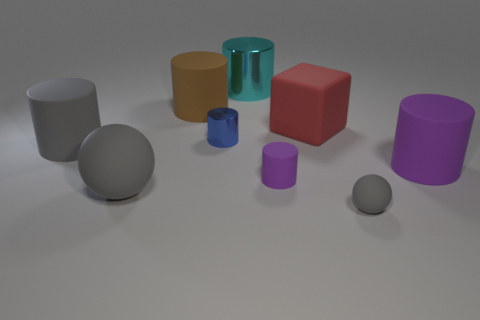Subtract 1 cylinders. How many cylinders are left? 5 Subtract all purple cylinders. How many cylinders are left? 4 Subtract all small cylinders. How many cylinders are left? 4 Subtract all cyan cylinders. Subtract all green balls. How many cylinders are left? 5 Add 1 big blue matte spheres. How many objects exist? 10 Subtract all cubes. How many objects are left? 8 Add 3 big cyan things. How many big cyan things are left? 4 Add 4 big purple objects. How many big purple objects exist? 5 Subtract 1 gray cylinders. How many objects are left? 8 Subtract all spheres. Subtract all rubber balls. How many objects are left? 5 